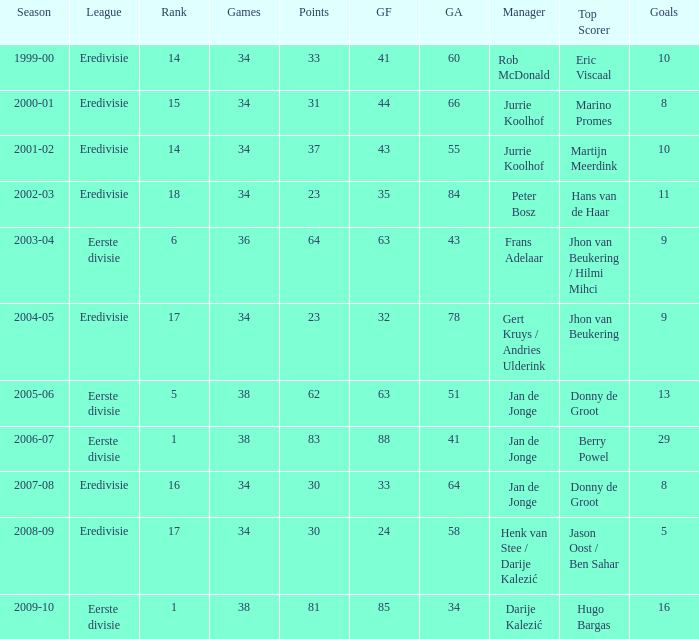How many seasons had a rank of 16? 1.0. 